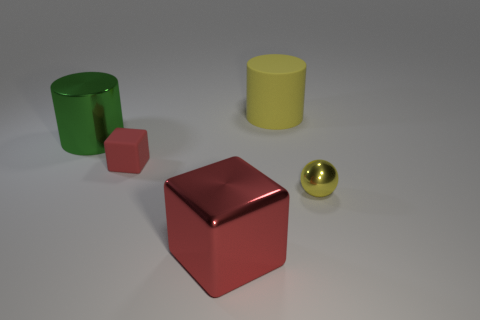Add 1 metallic cylinders. How many objects exist? 6 Subtract all balls. How many objects are left? 4 Subtract 1 red blocks. How many objects are left? 4 Subtract all large gray metallic cubes. Subtract all metallic things. How many objects are left? 2 Add 5 cylinders. How many cylinders are left? 7 Add 4 big metallic cylinders. How many big metallic cylinders exist? 5 